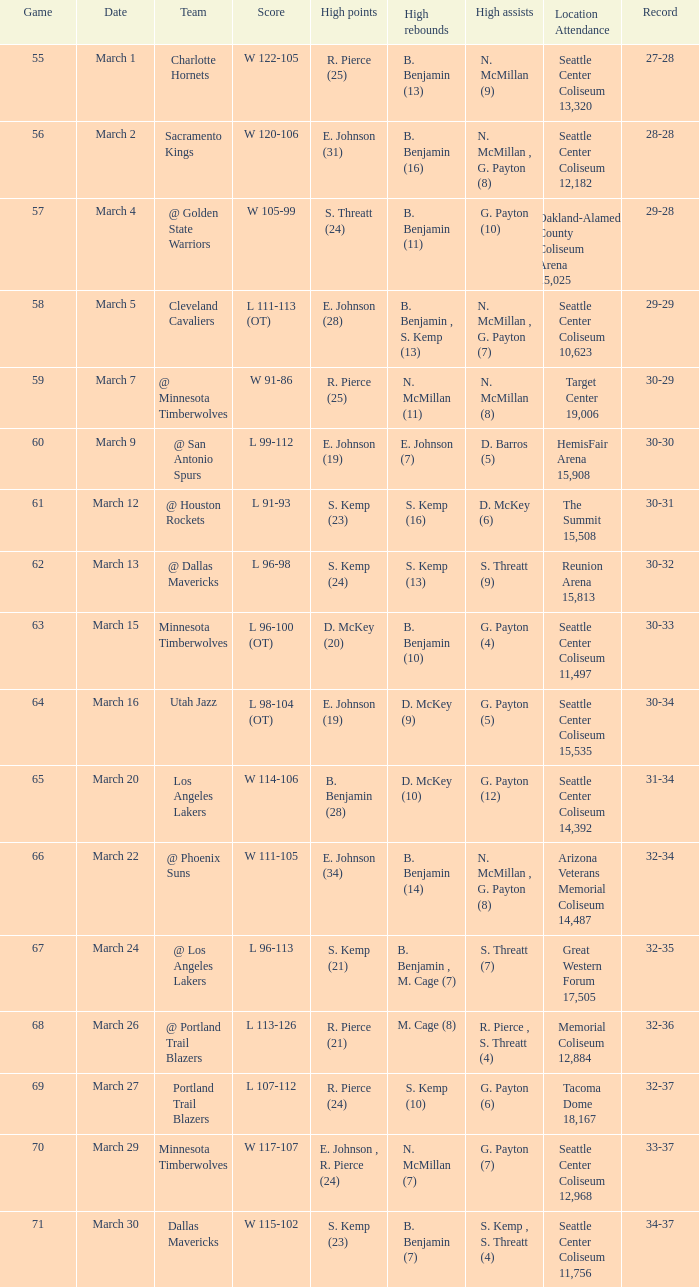Which game happened on march 2? 56.0. 